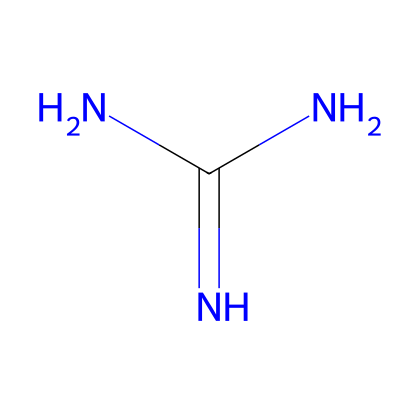What is the molecular formula of guanidine? The SMILES representation indicates the atoms present: N (nitrogen) and C (carbon). Counting the atoms gives one carbon atom and three nitrogen atoms, leading to the molecular formula of C1H7N5.
Answer: C1H7N5 How many nitrogen atoms are there in guanidine? By analyzing the SMILES notation, it's clear there are four nitrogen atoms connected to one carbon atom. Each 'N' in the notation corresponds to a nitrogen atom.
Answer: 4 What is the hybridization of the carbon atom in guanidine? The carbon is bonded to three nitrogen atoms and has a double bond to one of the nitrogen atoms, indicating it is sp2 hybridized, as it is part of a trigonal planar structure.
Answer: sp2 What type of base is guanidine classified as? Given the presence of multiple basic nitrogen atoms in the structure, guanidine can be classified as a superbase due to its strong basicity and ability to effectively accept protons.
Answer: superbase Does guanidine have a neutral charge? The structure indicates a balanced number of protons and electrons, meaning the molecule is neutral overall with no formal charges present on the atoms.
Answer: neutral What is the coordination geometry around the nitrogen atoms in guanidine? The nitrogen atoms in guanidine typically exhibit a trigonal planar geometry due to the sp2 hybridization, especially for those bonded to hydrogen.
Answer: trigonal planar 